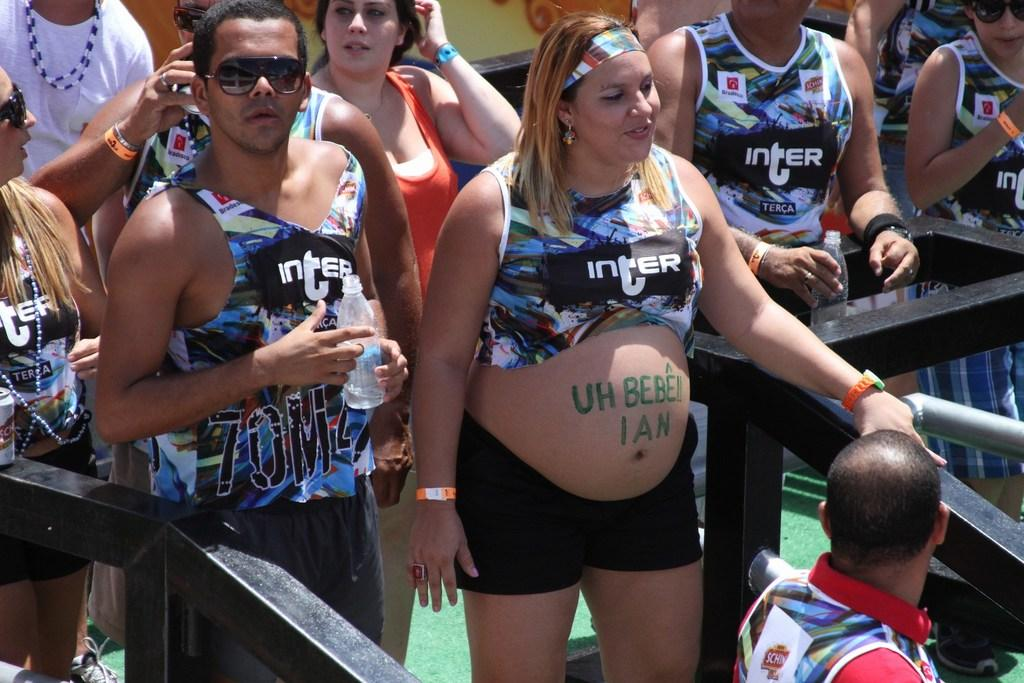Provide a one-sentence caption for the provided image. A group of people wearing Inter tanktops on a sunny day. 